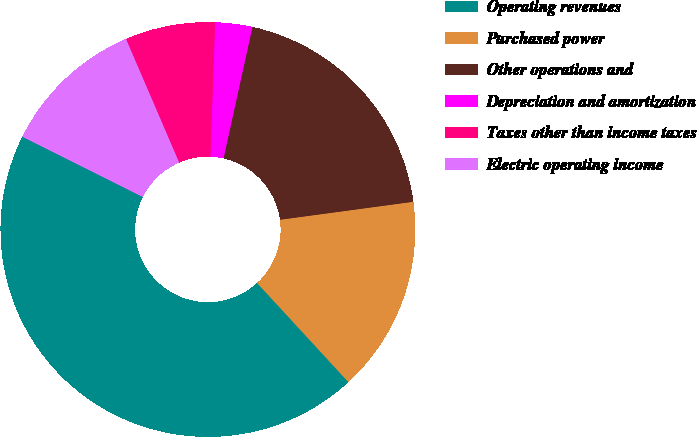Convert chart. <chart><loc_0><loc_0><loc_500><loc_500><pie_chart><fcel>Operating revenues<fcel>Purchased power<fcel>Other operations and<fcel>Depreciation and amortization<fcel>Taxes other than income taxes<fcel>Electric operating income<nl><fcel>44.23%<fcel>15.29%<fcel>19.42%<fcel>2.89%<fcel>7.02%<fcel>11.15%<nl></chart> 